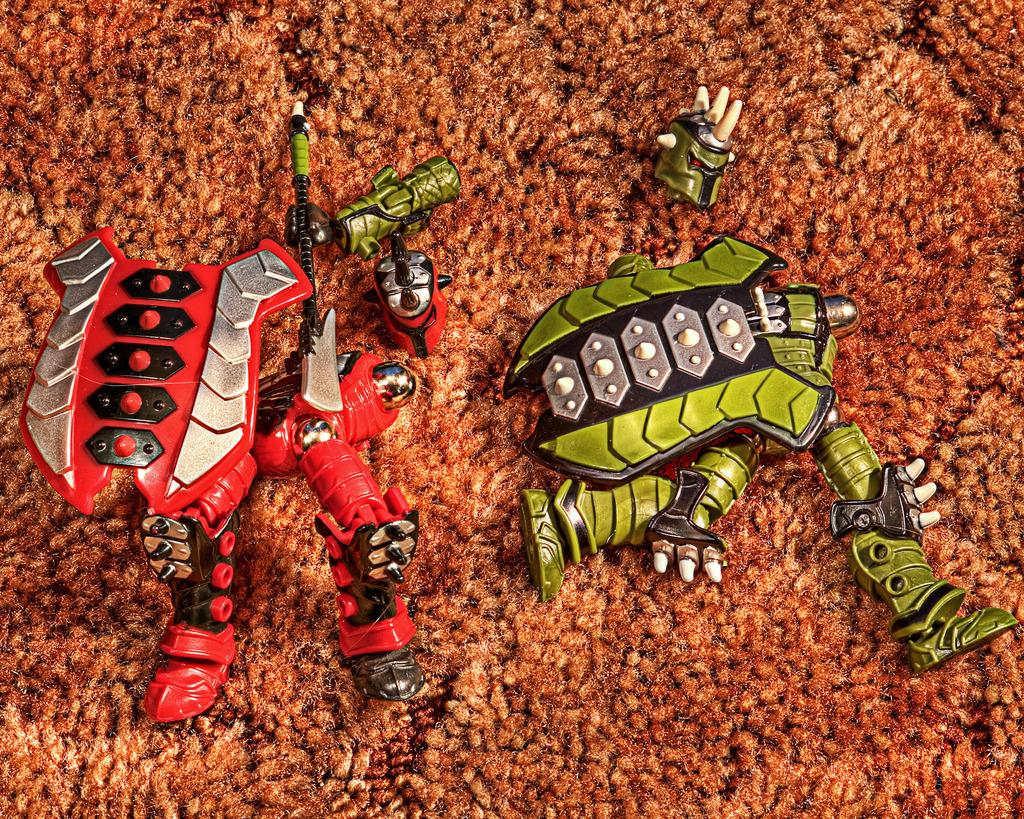What objects are present in the image? There are toys in the image. What is the color of the surface on which the toys are placed? The toys are on a brown color surface. What type of square snail can be seen crawling on the toys in the image? There is no snail, square or otherwise, present in the image. The image only features toys on a brown surface. 